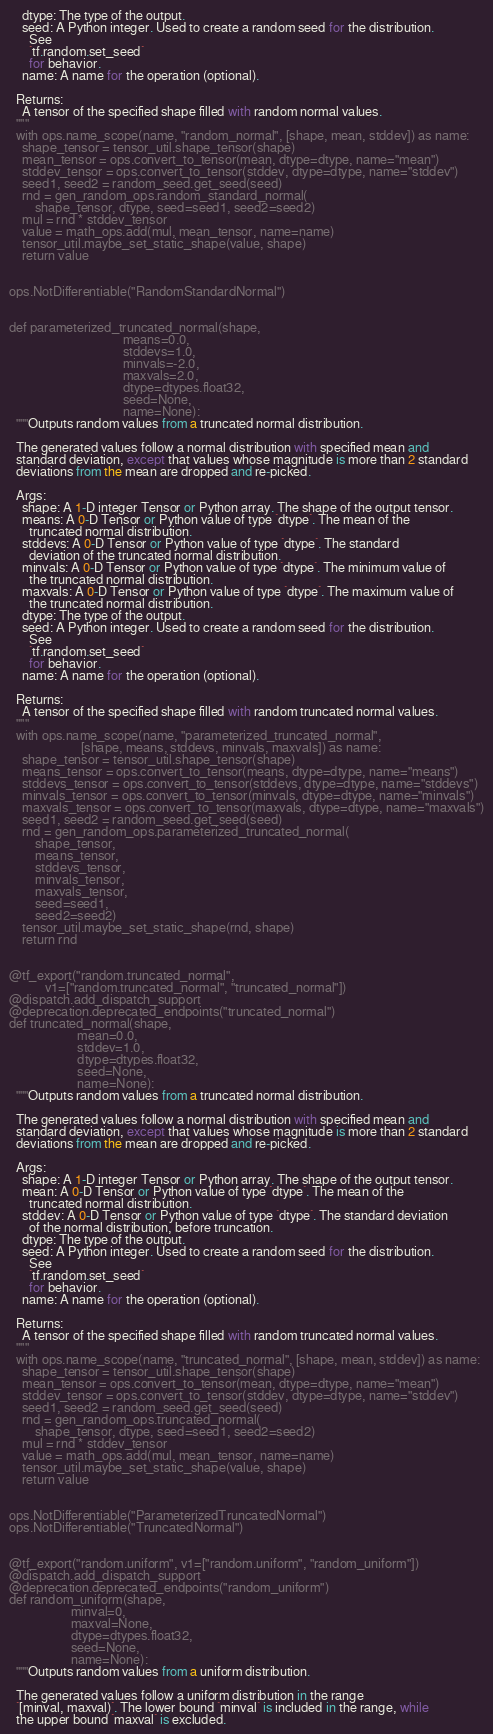<code> <loc_0><loc_0><loc_500><loc_500><_Python_>    dtype: The type of the output.
    seed: A Python integer. Used to create a random seed for the distribution.
      See
      `tf.random.set_seed`
      for behavior.
    name: A name for the operation (optional).

  Returns:
    A tensor of the specified shape filled with random normal values.
  """
  with ops.name_scope(name, "random_normal", [shape, mean, stddev]) as name:
    shape_tensor = tensor_util.shape_tensor(shape)
    mean_tensor = ops.convert_to_tensor(mean, dtype=dtype, name="mean")
    stddev_tensor = ops.convert_to_tensor(stddev, dtype=dtype, name="stddev")
    seed1, seed2 = random_seed.get_seed(seed)
    rnd = gen_random_ops.random_standard_normal(
        shape_tensor, dtype, seed=seed1, seed2=seed2)
    mul = rnd * stddev_tensor
    value = math_ops.add(mul, mean_tensor, name=name)
    tensor_util.maybe_set_static_shape(value, shape)
    return value


ops.NotDifferentiable("RandomStandardNormal")


def parameterized_truncated_normal(shape,
                                   means=0.0,
                                   stddevs=1.0,
                                   minvals=-2.0,
                                   maxvals=2.0,
                                   dtype=dtypes.float32,
                                   seed=None,
                                   name=None):
  """Outputs random values from a truncated normal distribution.

  The generated values follow a normal distribution with specified mean and
  standard deviation, except that values whose magnitude is more than 2 standard
  deviations from the mean are dropped and re-picked.

  Args:
    shape: A 1-D integer Tensor or Python array. The shape of the output tensor.
    means: A 0-D Tensor or Python value of type `dtype`. The mean of the
      truncated normal distribution.
    stddevs: A 0-D Tensor or Python value of type `dtype`. The standard
      deviation of the truncated normal distribution.
    minvals: A 0-D Tensor or Python value of type `dtype`. The minimum value of
      the truncated normal distribution.
    maxvals: A 0-D Tensor or Python value of type `dtype`. The maximum value of
      the truncated normal distribution.
    dtype: The type of the output.
    seed: A Python integer. Used to create a random seed for the distribution.
      See
      `tf.random.set_seed`
      for behavior.
    name: A name for the operation (optional).

  Returns:
    A tensor of the specified shape filled with random truncated normal values.
  """
  with ops.name_scope(name, "parameterized_truncated_normal",
                      [shape, means, stddevs, minvals, maxvals]) as name:
    shape_tensor = tensor_util.shape_tensor(shape)
    means_tensor = ops.convert_to_tensor(means, dtype=dtype, name="means")
    stddevs_tensor = ops.convert_to_tensor(stddevs, dtype=dtype, name="stddevs")
    minvals_tensor = ops.convert_to_tensor(minvals, dtype=dtype, name="minvals")
    maxvals_tensor = ops.convert_to_tensor(maxvals, dtype=dtype, name="maxvals")
    seed1, seed2 = random_seed.get_seed(seed)
    rnd = gen_random_ops.parameterized_truncated_normal(
        shape_tensor,
        means_tensor,
        stddevs_tensor,
        minvals_tensor,
        maxvals_tensor,
        seed=seed1,
        seed2=seed2)
    tensor_util.maybe_set_static_shape(rnd, shape)
    return rnd


@tf_export("random.truncated_normal",
           v1=["random.truncated_normal", "truncated_normal"])
@dispatch.add_dispatch_support
@deprecation.deprecated_endpoints("truncated_normal")
def truncated_normal(shape,
                     mean=0.0,
                     stddev=1.0,
                     dtype=dtypes.float32,
                     seed=None,
                     name=None):
  """Outputs random values from a truncated normal distribution.

  The generated values follow a normal distribution with specified mean and
  standard deviation, except that values whose magnitude is more than 2 standard
  deviations from the mean are dropped and re-picked.

  Args:
    shape: A 1-D integer Tensor or Python array. The shape of the output tensor.
    mean: A 0-D Tensor or Python value of type `dtype`. The mean of the
      truncated normal distribution.
    stddev: A 0-D Tensor or Python value of type `dtype`. The standard deviation
      of the normal distribution, before truncation.
    dtype: The type of the output.
    seed: A Python integer. Used to create a random seed for the distribution.
      See
      `tf.random.set_seed`
      for behavior.
    name: A name for the operation (optional).

  Returns:
    A tensor of the specified shape filled with random truncated normal values.
  """
  with ops.name_scope(name, "truncated_normal", [shape, mean, stddev]) as name:
    shape_tensor = tensor_util.shape_tensor(shape)
    mean_tensor = ops.convert_to_tensor(mean, dtype=dtype, name="mean")
    stddev_tensor = ops.convert_to_tensor(stddev, dtype=dtype, name="stddev")
    seed1, seed2 = random_seed.get_seed(seed)
    rnd = gen_random_ops.truncated_normal(
        shape_tensor, dtype, seed=seed1, seed2=seed2)
    mul = rnd * stddev_tensor
    value = math_ops.add(mul, mean_tensor, name=name)
    tensor_util.maybe_set_static_shape(value, shape)
    return value


ops.NotDifferentiable("ParameterizedTruncatedNormal")
ops.NotDifferentiable("TruncatedNormal")


@tf_export("random.uniform", v1=["random.uniform", "random_uniform"])
@dispatch.add_dispatch_support
@deprecation.deprecated_endpoints("random_uniform")
def random_uniform(shape,
                   minval=0,
                   maxval=None,
                   dtype=dtypes.float32,
                   seed=None,
                   name=None):
  """Outputs random values from a uniform distribution.

  The generated values follow a uniform distribution in the range
  `[minval, maxval)`. The lower bound `minval` is included in the range, while
  the upper bound `maxval` is excluded.
</code> 